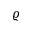<formula> <loc_0><loc_0><loc_500><loc_500>\varrho</formula> 